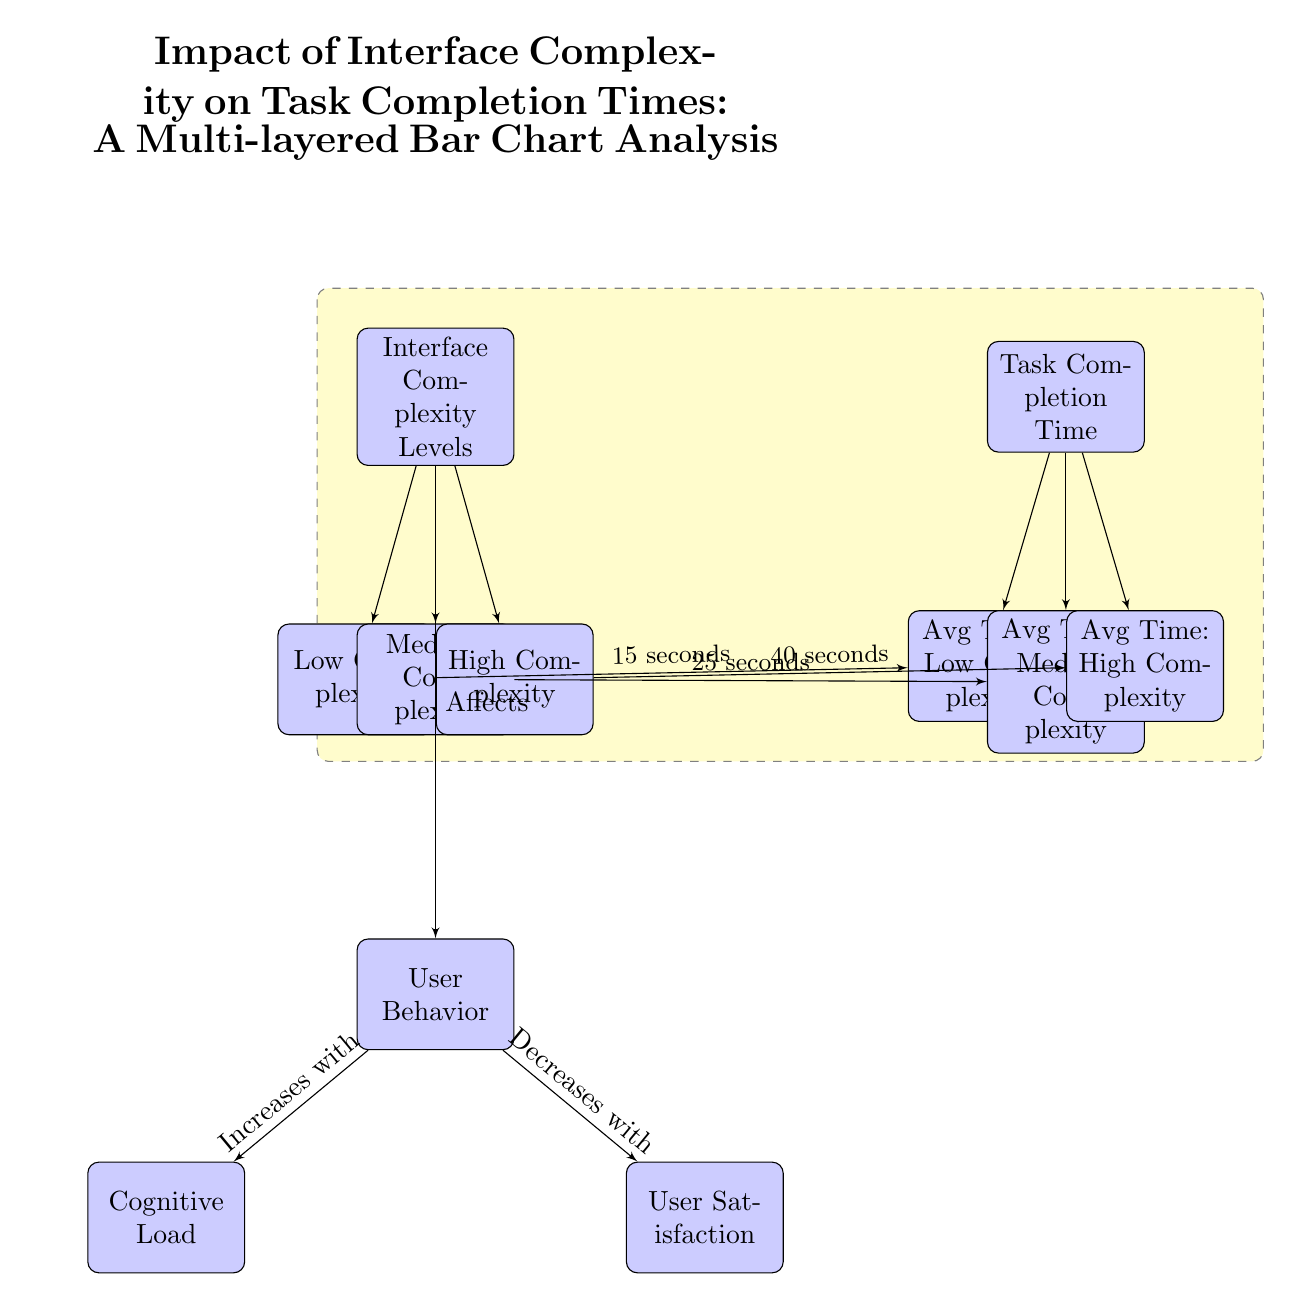What are the three levels of interface complexity shown in the diagram? The diagram lists three levels of interface complexity: Low Complexity, Medium Complexity, and High Complexity. These are explicitly named in the blocks below the "Interface Complexity Levels" block.
Answer: Low Complexity, Medium Complexity, High Complexity What is the average task completion time for low complexity interfaces? The average completion time for low complexity interfaces is indicated as 15 seconds directly beneath the "Avg Time: Low Complexity" block, which is connected to the "Low Complexity" node.
Answer: 15 seconds How does user satisfaction relate to interface complexity? The diagram shows that user satisfaction decreases with increasing interface complexity, as indicated by the arrow from the "User Behavior" block to the "User Satisfaction" block, labeled as "Decreases with."
Answer: Decreases What happens to cognitive load as interface complexity increases? The diagram indicates that cognitive load increases as the interface complexity increases. This is shown by the relationship between the "User Behavior" block and the "Cognitive Load" block, with the label "Increases with."
Answer: Increases What is the average task completion time for high complexity interfaces? The average task completion time for high complexity interfaces is shown as 40 seconds in the block labeled "Avg Time: High Complexity," which is connected to the "High Complexity" node.
Answer: 40 seconds How many connections are there from the "Interface Complexity Levels" block to the "Task Completion Time" block? There are three connections from the "Interface Complexity Levels" block to the "Task Completion Time" block, one for each complexity level: low, medium, and high. Each level points to its corresponding average time block.
Answer: 3 What is the relationship between task completion time and interface complexity? The diagram illustrates that task completion time increases as interface complexity levels increase: 15 seconds for low, 25 seconds for medium, and 40 seconds for high complexity. This indicates a positive correlation between the two variables.
Answer: Increases How is the "Task Completion Time" block connected to the "Cognitive Load" block? There is no direct connection between the "Task Completion Time" block and the "Cognitive Load" block, but both are influenced by the interface complexity. This implies an indirect relationship mediated by user behavior.
Answer: Indirectly related 